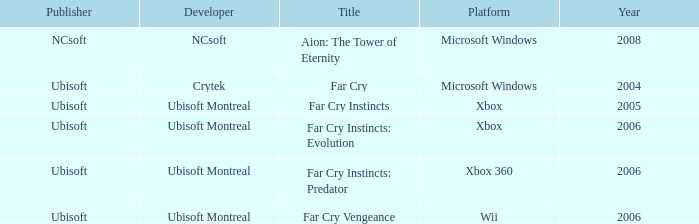Which publisher has Far Cry as the title? Ubisoft. 